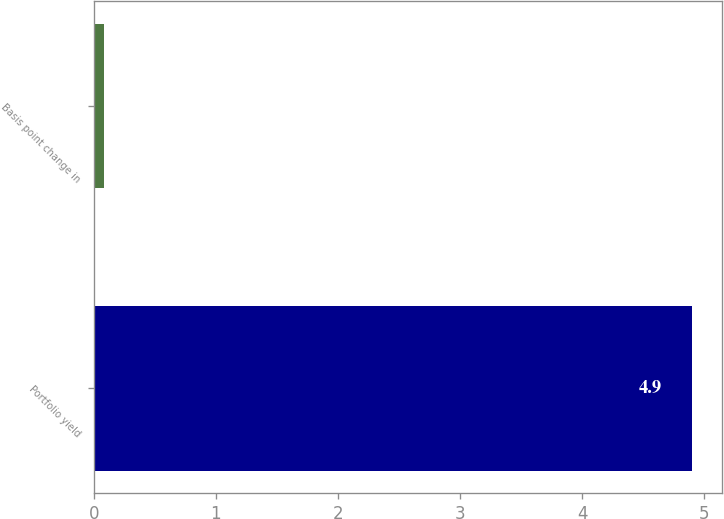Convert chart. <chart><loc_0><loc_0><loc_500><loc_500><bar_chart><fcel>Portfolio yield<fcel>Basis point change in<nl><fcel>4.9<fcel>0.08<nl></chart> 